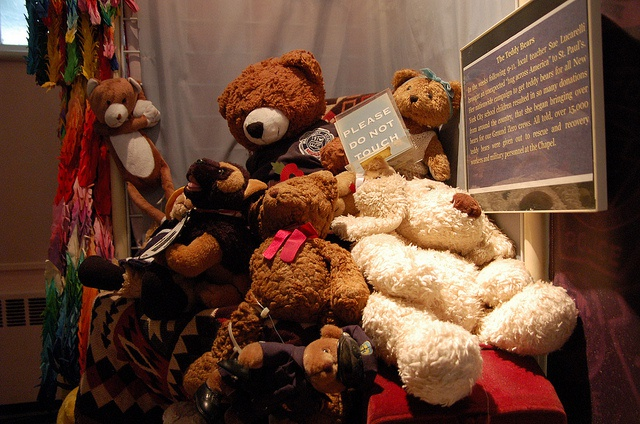Describe the objects in this image and their specific colors. I can see teddy bear in lightblue, tan, beige, and brown tones, teddy bear in lightblue, black, maroon, and brown tones, teddy bear in lightblue, black, maroon, and brown tones, teddy bear in lightblue, black, maroon, and brown tones, and teddy bear in lightblue, black, maroon, brown, and tan tones in this image. 